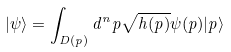<formula> <loc_0><loc_0><loc_500><loc_500>| \psi \rangle = \int _ { D ( p ) } d ^ { n } p \sqrt { h ( p ) } \psi ( p ) | p \rangle</formula> 